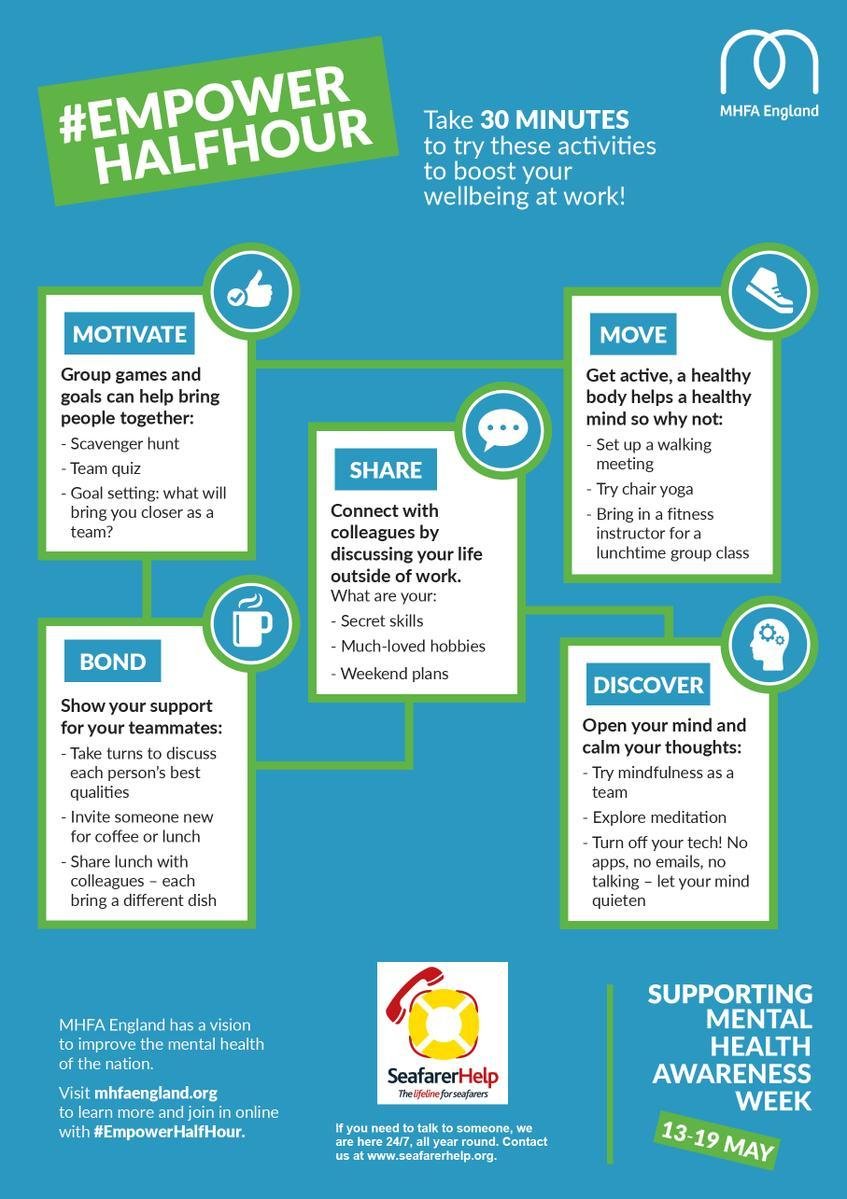Which is the second group game listed?
Answer the question with a short phrase. Team quiz What is the second suggestion listed to calm your thoughts? explore meditation Which is the first group game listed? scavenger hunt What type of meeting can you arrange that helps you get active? walking meeting 